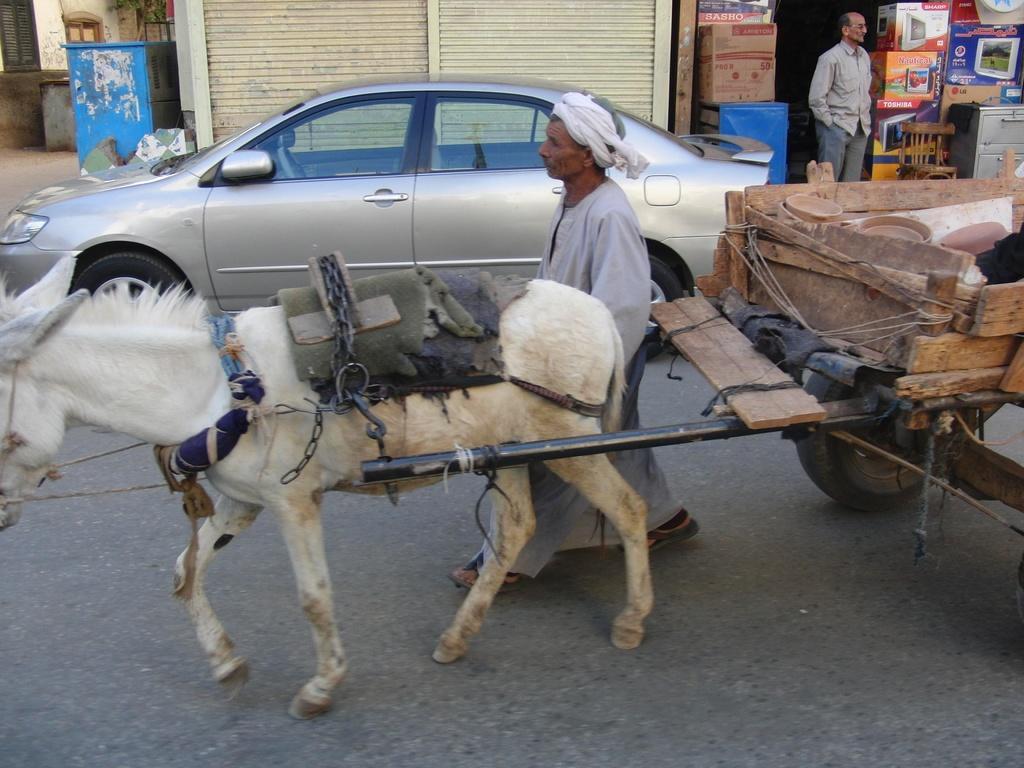Can you describe this image briefly? Here we can see a horse with cart. Beside this house there is a person and vehicle. These are stores. Here we can see cardboard boxes, chair and person. These are windows. 